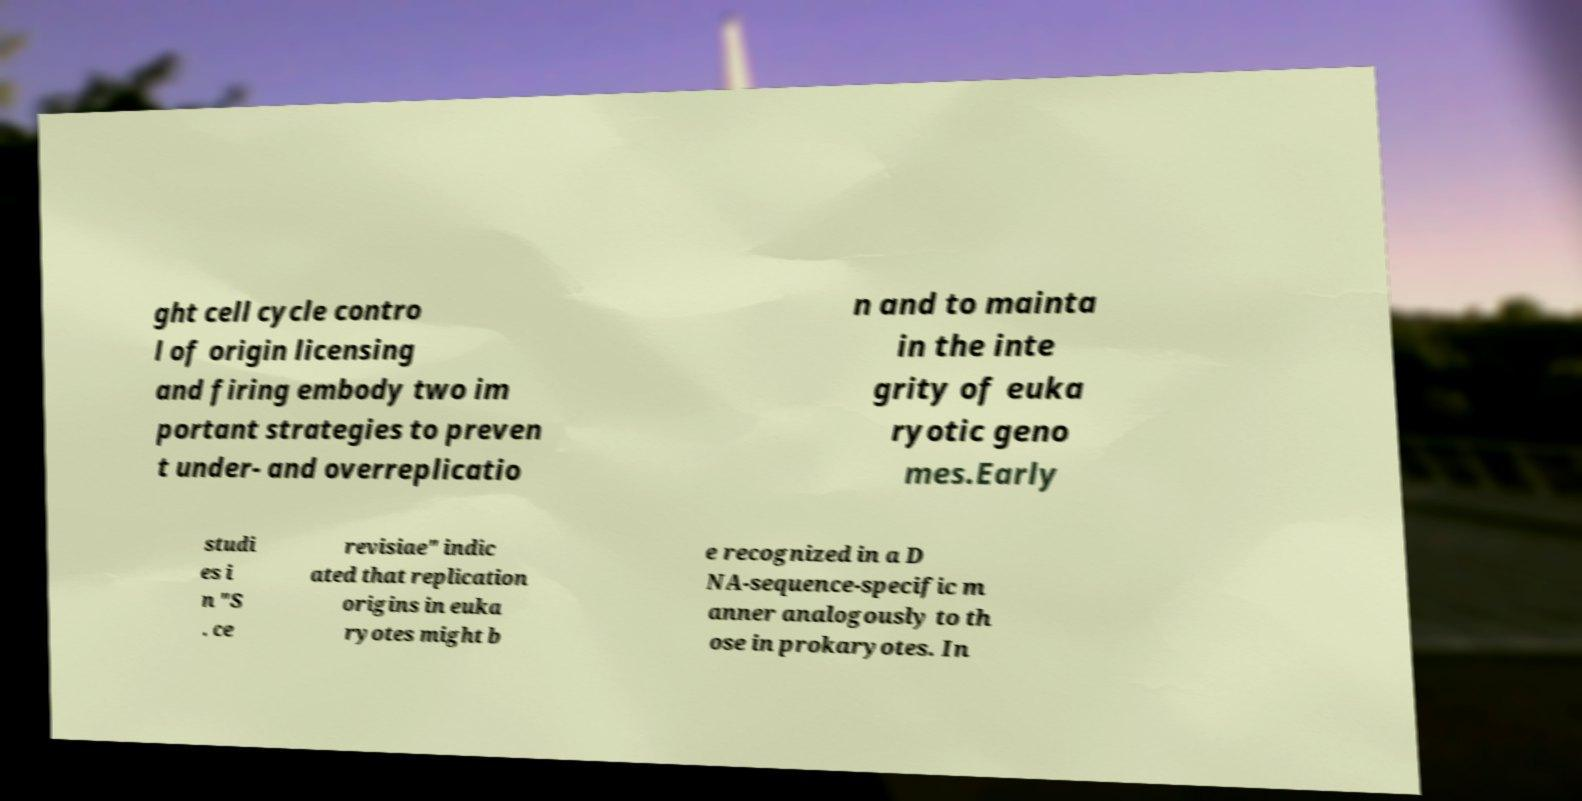Can you accurately transcribe the text from the provided image for me? ght cell cycle contro l of origin licensing and firing embody two im portant strategies to preven t under- and overreplicatio n and to mainta in the inte grity of euka ryotic geno mes.Early studi es i n "S . ce revisiae" indic ated that replication origins in euka ryotes might b e recognized in a D NA-sequence-specific m anner analogously to th ose in prokaryotes. In 